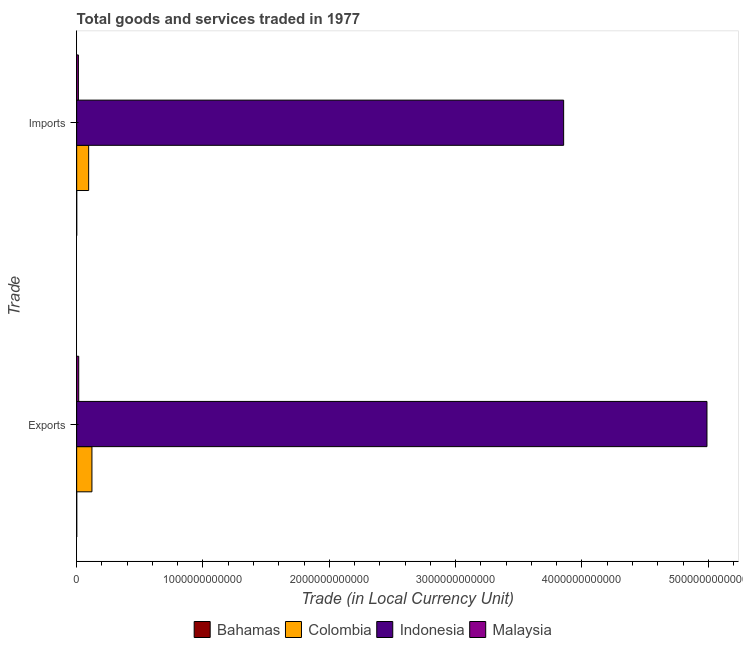How many different coloured bars are there?
Make the answer very short. 4. How many groups of bars are there?
Offer a terse response. 2. How many bars are there on the 2nd tick from the top?
Offer a very short reply. 4. What is the label of the 1st group of bars from the top?
Your response must be concise. Imports. What is the imports of goods and services in Malaysia?
Your answer should be compact. 1.38e+1. Across all countries, what is the maximum export of goods and services?
Your answer should be very brief. 4.99e+12. Across all countries, what is the minimum imports of goods and services?
Your answer should be compact. 4.72e+08. In which country was the imports of goods and services minimum?
Offer a terse response. Bahamas. What is the total export of goods and services in the graph?
Your response must be concise. 5.13e+12. What is the difference between the imports of goods and services in Malaysia and that in Indonesia?
Your answer should be compact. -3.84e+12. What is the difference between the imports of goods and services in Malaysia and the export of goods and services in Bahamas?
Make the answer very short. 1.32e+1. What is the average imports of goods and services per country?
Your response must be concise. 9.91e+11. What is the difference between the imports of goods and services and export of goods and services in Malaysia?
Your answer should be very brief. -2.46e+09. In how many countries, is the export of goods and services greater than 3400000000000 LCU?
Your answer should be very brief. 1. What is the ratio of the export of goods and services in Indonesia to that in Colombia?
Ensure brevity in your answer.  41.24. What does the 4th bar from the top in Imports represents?
Ensure brevity in your answer.  Bahamas. What does the 1st bar from the bottom in Imports represents?
Give a very brief answer. Bahamas. How many bars are there?
Give a very brief answer. 8. Are all the bars in the graph horizontal?
Offer a terse response. Yes. What is the difference between two consecutive major ticks on the X-axis?
Your response must be concise. 1.00e+12. Are the values on the major ticks of X-axis written in scientific E-notation?
Keep it short and to the point. No. Does the graph contain any zero values?
Offer a terse response. No. Does the graph contain grids?
Provide a short and direct response. No. Where does the legend appear in the graph?
Provide a short and direct response. Bottom center. How many legend labels are there?
Ensure brevity in your answer.  4. How are the legend labels stacked?
Your answer should be compact. Horizontal. What is the title of the graph?
Offer a very short reply. Total goods and services traded in 1977. What is the label or title of the X-axis?
Make the answer very short. Trade (in Local Currency Unit). What is the label or title of the Y-axis?
Keep it short and to the point. Trade. What is the Trade (in Local Currency Unit) of Bahamas in Exports?
Give a very brief answer. 5.89e+08. What is the Trade (in Local Currency Unit) of Colombia in Exports?
Keep it short and to the point. 1.21e+11. What is the Trade (in Local Currency Unit) in Indonesia in Exports?
Your answer should be compact. 4.99e+12. What is the Trade (in Local Currency Unit) of Malaysia in Exports?
Ensure brevity in your answer.  1.63e+1. What is the Trade (in Local Currency Unit) in Bahamas in Imports?
Provide a succinct answer. 4.72e+08. What is the Trade (in Local Currency Unit) in Colombia in Imports?
Your response must be concise. 9.50e+1. What is the Trade (in Local Currency Unit) of Indonesia in Imports?
Ensure brevity in your answer.  3.86e+12. What is the Trade (in Local Currency Unit) of Malaysia in Imports?
Keep it short and to the point. 1.38e+1. Across all Trade, what is the maximum Trade (in Local Currency Unit) of Bahamas?
Provide a succinct answer. 5.89e+08. Across all Trade, what is the maximum Trade (in Local Currency Unit) in Colombia?
Offer a very short reply. 1.21e+11. Across all Trade, what is the maximum Trade (in Local Currency Unit) of Indonesia?
Provide a succinct answer. 4.99e+12. Across all Trade, what is the maximum Trade (in Local Currency Unit) in Malaysia?
Ensure brevity in your answer.  1.63e+1. Across all Trade, what is the minimum Trade (in Local Currency Unit) of Bahamas?
Your response must be concise. 4.72e+08. Across all Trade, what is the minimum Trade (in Local Currency Unit) of Colombia?
Keep it short and to the point. 9.50e+1. Across all Trade, what is the minimum Trade (in Local Currency Unit) of Indonesia?
Your answer should be compact. 3.86e+12. Across all Trade, what is the minimum Trade (in Local Currency Unit) of Malaysia?
Your response must be concise. 1.38e+1. What is the total Trade (in Local Currency Unit) of Bahamas in the graph?
Offer a terse response. 1.06e+09. What is the total Trade (in Local Currency Unit) of Colombia in the graph?
Your answer should be compact. 2.16e+11. What is the total Trade (in Local Currency Unit) of Indonesia in the graph?
Your answer should be very brief. 8.85e+12. What is the total Trade (in Local Currency Unit) of Malaysia in the graph?
Your answer should be very brief. 3.01e+1. What is the difference between the Trade (in Local Currency Unit) in Bahamas in Exports and that in Imports?
Make the answer very short. 1.18e+08. What is the difference between the Trade (in Local Currency Unit) in Colombia in Exports and that in Imports?
Your answer should be very brief. 2.60e+1. What is the difference between the Trade (in Local Currency Unit) in Indonesia in Exports and that in Imports?
Make the answer very short. 1.13e+12. What is the difference between the Trade (in Local Currency Unit) of Malaysia in Exports and that in Imports?
Provide a succinct answer. 2.46e+09. What is the difference between the Trade (in Local Currency Unit) in Bahamas in Exports and the Trade (in Local Currency Unit) in Colombia in Imports?
Provide a succinct answer. -9.44e+1. What is the difference between the Trade (in Local Currency Unit) in Bahamas in Exports and the Trade (in Local Currency Unit) in Indonesia in Imports?
Give a very brief answer. -3.85e+12. What is the difference between the Trade (in Local Currency Unit) of Bahamas in Exports and the Trade (in Local Currency Unit) of Malaysia in Imports?
Offer a very short reply. -1.32e+1. What is the difference between the Trade (in Local Currency Unit) of Colombia in Exports and the Trade (in Local Currency Unit) of Indonesia in Imports?
Offer a terse response. -3.73e+12. What is the difference between the Trade (in Local Currency Unit) of Colombia in Exports and the Trade (in Local Currency Unit) of Malaysia in Imports?
Your response must be concise. 1.07e+11. What is the difference between the Trade (in Local Currency Unit) in Indonesia in Exports and the Trade (in Local Currency Unit) in Malaysia in Imports?
Your answer should be very brief. 4.98e+12. What is the average Trade (in Local Currency Unit) in Bahamas per Trade?
Offer a very short reply. 5.30e+08. What is the average Trade (in Local Currency Unit) of Colombia per Trade?
Make the answer very short. 1.08e+11. What is the average Trade (in Local Currency Unit) of Indonesia per Trade?
Your response must be concise. 4.42e+12. What is the average Trade (in Local Currency Unit) of Malaysia per Trade?
Provide a succinct answer. 1.51e+1. What is the difference between the Trade (in Local Currency Unit) of Bahamas and Trade (in Local Currency Unit) of Colombia in Exports?
Provide a short and direct response. -1.20e+11. What is the difference between the Trade (in Local Currency Unit) of Bahamas and Trade (in Local Currency Unit) of Indonesia in Exports?
Provide a short and direct response. -4.99e+12. What is the difference between the Trade (in Local Currency Unit) in Bahamas and Trade (in Local Currency Unit) in Malaysia in Exports?
Your answer should be compact. -1.57e+1. What is the difference between the Trade (in Local Currency Unit) of Colombia and Trade (in Local Currency Unit) of Indonesia in Exports?
Your response must be concise. -4.87e+12. What is the difference between the Trade (in Local Currency Unit) in Colombia and Trade (in Local Currency Unit) in Malaysia in Exports?
Offer a very short reply. 1.05e+11. What is the difference between the Trade (in Local Currency Unit) in Indonesia and Trade (in Local Currency Unit) in Malaysia in Exports?
Provide a succinct answer. 4.97e+12. What is the difference between the Trade (in Local Currency Unit) in Bahamas and Trade (in Local Currency Unit) in Colombia in Imports?
Give a very brief answer. -9.45e+1. What is the difference between the Trade (in Local Currency Unit) of Bahamas and Trade (in Local Currency Unit) of Indonesia in Imports?
Ensure brevity in your answer.  -3.85e+12. What is the difference between the Trade (in Local Currency Unit) in Bahamas and Trade (in Local Currency Unit) in Malaysia in Imports?
Give a very brief answer. -1.34e+1. What is the difference between the Trade (in Local Currency Unit) in Colombia and Trade (in Local Currency Unit) in Indonesia in Imports?
Offer a terse response. -3.76e+12. What is the difference between the Trade (in Local Currency Unit) of Colombia and Trade (in Local Currency Unit) of Malaysia in Imports?
Your response must be concise. 8.12e+1. What is the difference between the Trade (in Local Currency Unit) of Indonesia and Trade (in Local Currency Unit) of Malaysia in Imports?
Keep it short and to the point. 3.84e+12. What is the ratio of the Trade (in Local Currency Unit) in Bahamas in Exports to that in Imports?
Provide a short and direct response. 1.25. What is the ratio of the Trade (in Local Currency Unit) in Colombia in Exports to that in Imports?
Keep it short and to the point. 1.27. What is the ratio of the Trade (in Local Currency Unit) in Indonesia in Exports to that in Imports?
Offer a terse response. 1.29. What is the ratio of the Trade (in Local Currency Unit) in Malaysia in Exports to that in Imports?
Offer a terse response. 1.18. What is the difference between the highest and the second highest Trade (in Local Currency Unit) of Bahamas?
Provide a succinct answer. 1.18e+08. What is the difference between the highest and the second highest Trade (in Local Currency Unit) of Colombia?
Your answer should be very brief. 2.60e+1. What is the difference between the highest and the second highest Trade (in Local Currency Unit) of Indonesia?
Offer a terse response. 1.13e+12. What is the difference between the highest and the second highest Trade (in Local Currency Unit) in Malaysia?
Provide a short and direct response. 2.46e+09. What is the difference between the highest and the lowest Trade (in Local Currency Unit) in Bahamas?
Make the answer very short. 1.18e+08. What is the difference between the highest and the lowest Trade (in Local Currency Unit) of Colombia?
Keep it short and to the point. 2.60e+1. What is the difference between the highest and the lowest Trade (in Local Currency Unit) in Indonesia?
Your answer should be compact. 1.13e+12. What is the difference between the highest and the lowest Trade (in Local Currency Unit) in Malaysia?
Provide a succinct answer. 2.46e+09. 